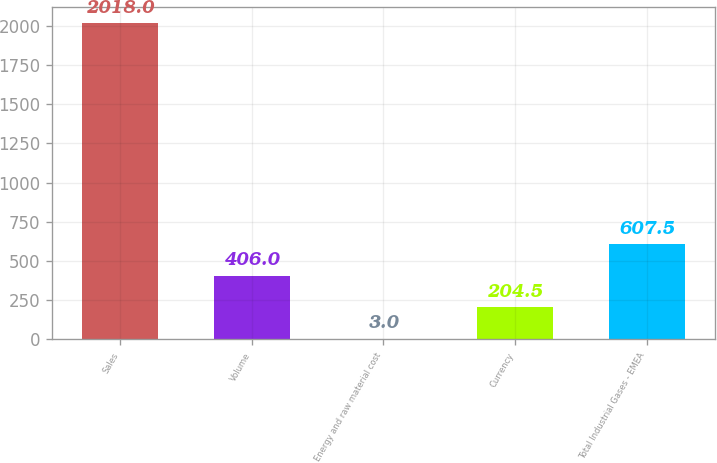Convert chart to OTSL. <chart><loc_0><loc_0><loc_500><loc_500><bar_chart><fcel>Sales<fcel>Volume<fcel>Energy and raw material cost<fcel>Currency<fcel>Total Industrial Gases - EMEA<nl><fcel>2018<fcel>406<fcel>3<fcel>204.5<fcel>607.5<nl></chart> 